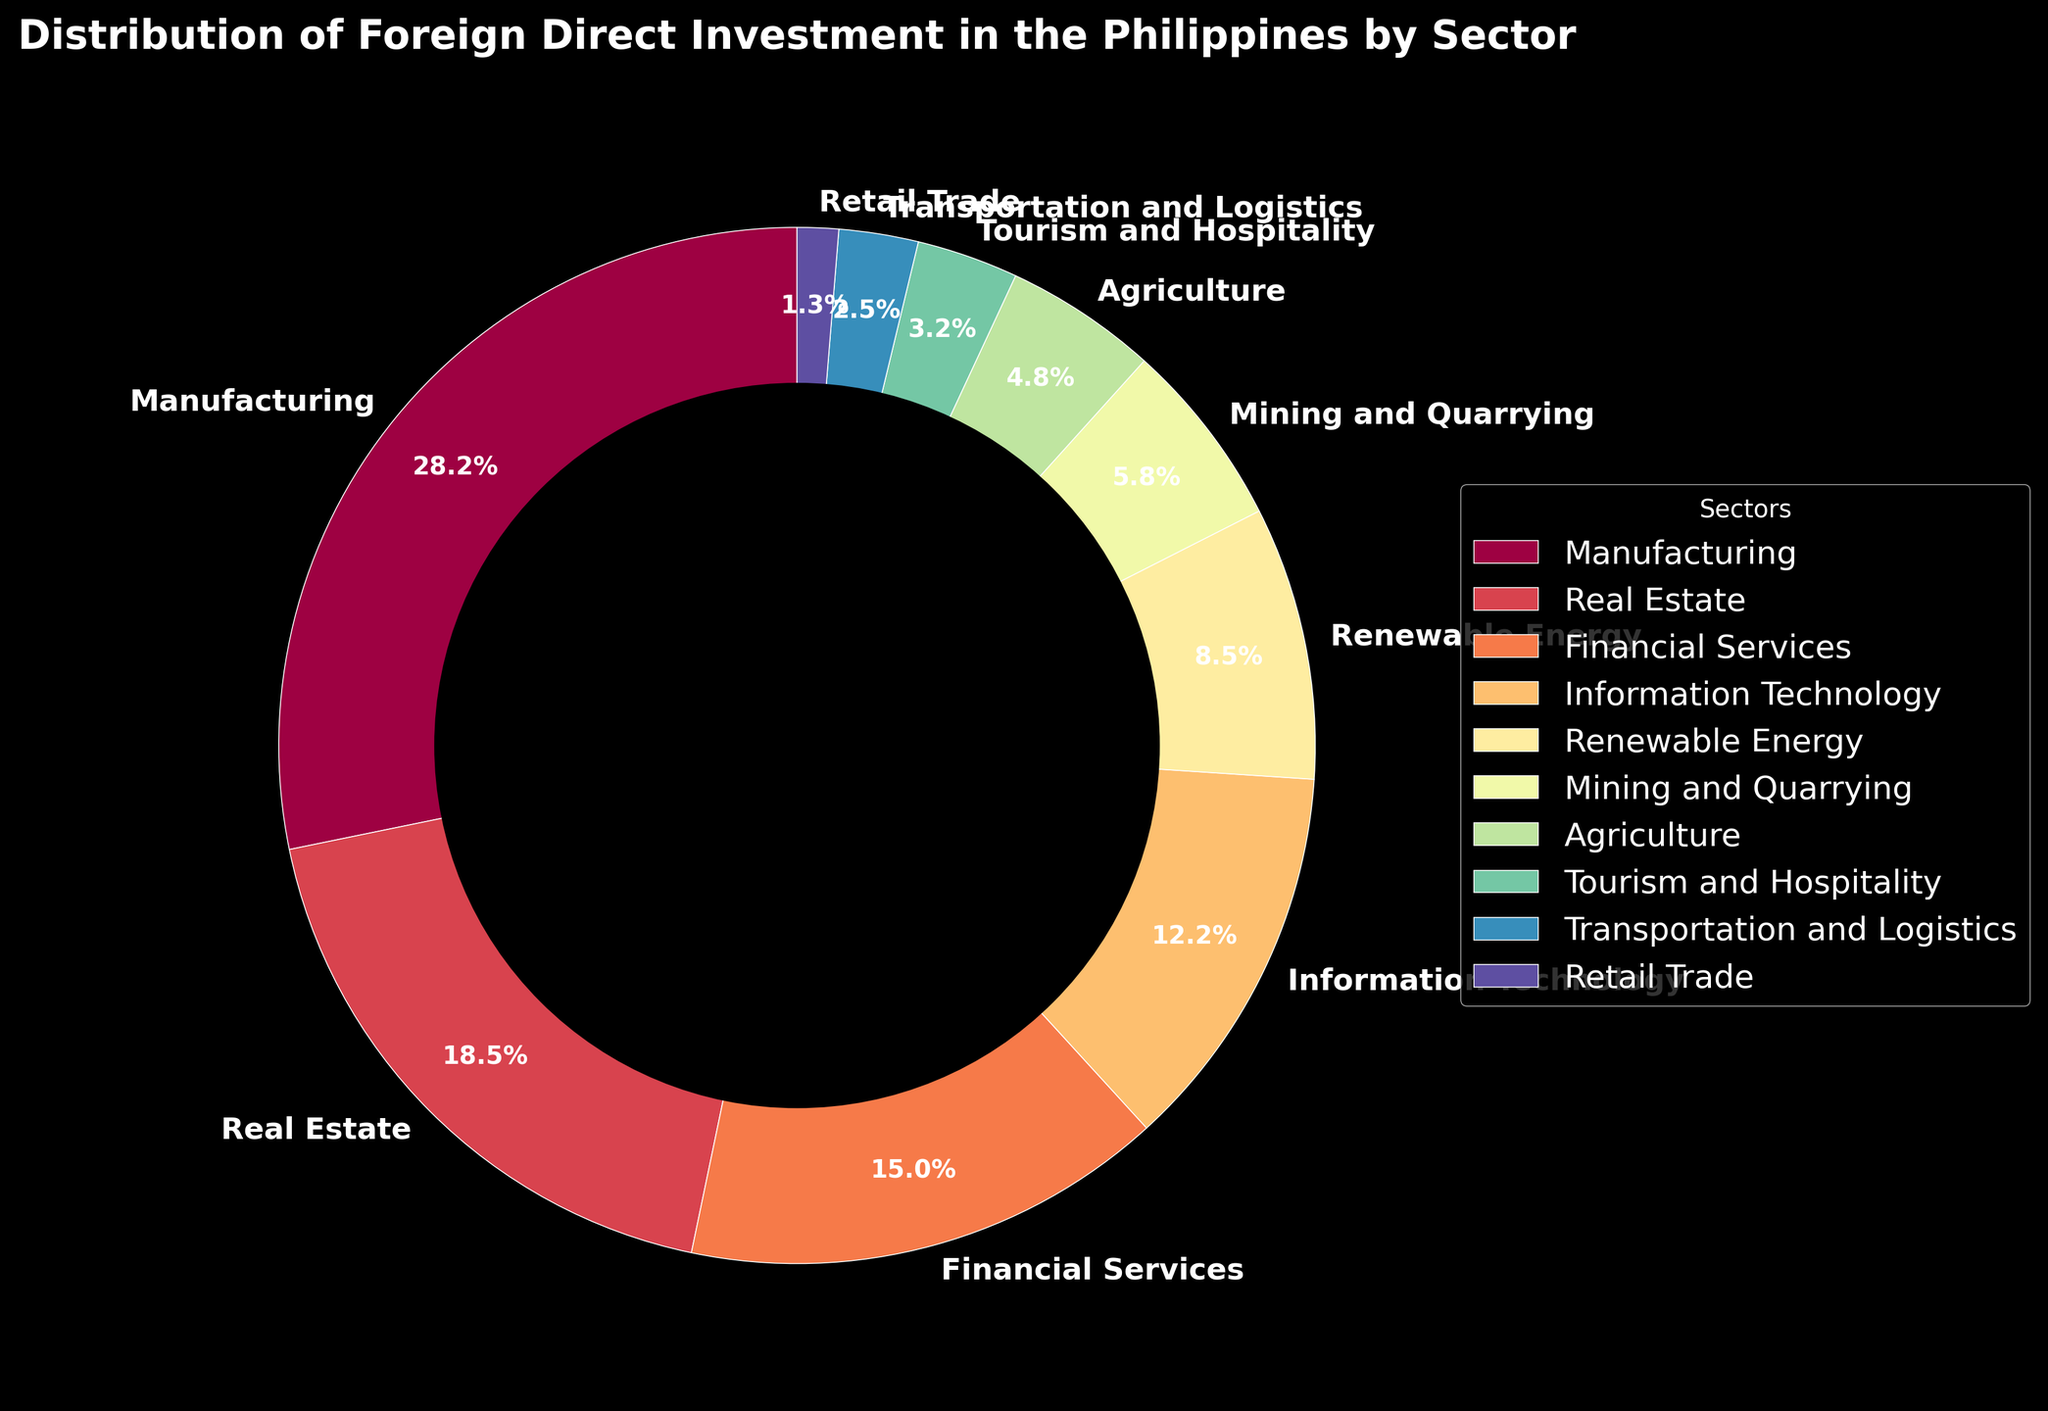Which sector has the highest percentage of foreign direct investment? The sector with the highest percentage is easily identifiable by looking for the largest wedge in the pie chart. This wedge represents Manufacturing, which has the highest percentage.
Answer: Manufacturing What is the percentage difference in FDI between Manufacturing and Real Estate sectors? Look at the pie chart to find the percentages for Manufacturing (28.5%) and Real Estate (18.7%). Subtract the smaller value from the larger value: 28.5 - 18.7 = 9.8%.
Answer: 9.8% Which sectors combined amount to more than 50% of the total foreign direct investment? Sum the percentages from the largest sector downwards until the total exceeds 50%. Adding Manufacturing (28.5%), Real Estate (18.7%), and Financial Services (15.2%) gives 62.4%.
Answer: Manufacturing, Real Estate, Financial Services Is the FDI in Information Technology more than double that in Agriculture? Compare the percentages for Information Technology (12.3%) and Agriculture (4.8%). Double Agriculture's percentage: 4.8 * 2 = 9.6. Since 12.3 > 9.6, IT's percentage is more than double Agriculture's.
Answer: Yes Which sector has the smallest share of FDI? How much is it? Identify the smallest wedge in the pie chart. This wedge represents Retail Trade, which has the smallest percentage.
Answer: Retail Trade, 1.3% How does the FDI in Mining and Quarrying compare to that in Renewable Energy? Compare the percentages for Mining and Quarrying (5.9%) and Renewable Energy (8.6%). Since 5.9 < 8.6, Mining and Quarrying has less FDI than Renewable Energy.
Answer: Less What is the cumulative FDI percentage for Tourism and Hospitality, Transportation and Logistics, and Retail Trade? Sum the percentages for Tourism and Hospitality (3.2%), Transportation and Logistics (2.5%), and Retail Trade (1.3%). 3.2 + 2.5 + 1.3 = 7.0%.
Answer: 7.0% Between which two sectors is the percentage difference the smallest? Calculate the differences between each pair of sectors. The smallest difference is between Transportation and Logistics (2.5%) and Retail Trade (1.3%), which is 2.5 - 1.3 = 1.2%.
Answer: Transportation and Logistics and Retail Trade Which sectors have a combined FDI contribution that is less than that of Information Technology? Find sectors with lower combined percentages than Information Technology (12.3%). Adding any three below IT can confirm this: Agriculture (4.8%) + Tourism and Hospitality (3.2%) + Transportation and Logistics (2.5%) = 10.5%.
Answer: Agriculture, Tourism and Hospitality, Transportation and Logistics What is the total FDI percentage contributed by Financial Services, Information Technology, and Renewable Energy? Sum the sector percentages: Financial Services (15.2%), Information Technology (12.3%), and Renewable Energy (8.6%). 15.2 + 12.3 + 8.6 = 36.1%.
Answer: 36.1% 